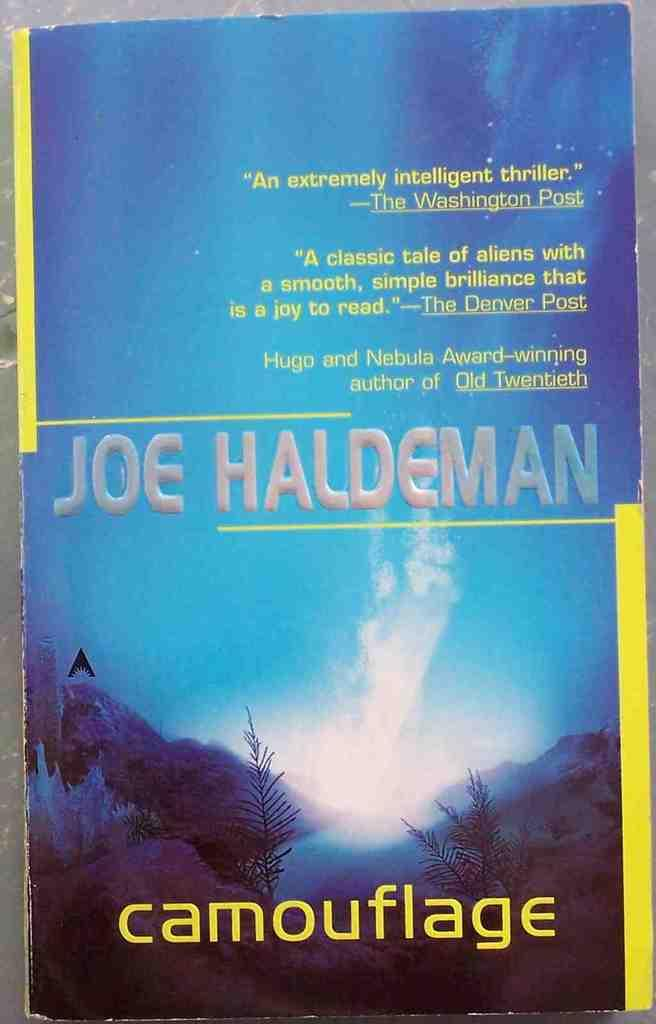<image>
Render a clear and concise summary of the photo. A book entitled Camouflage by Joe Haldeman with quotes on the cover. 